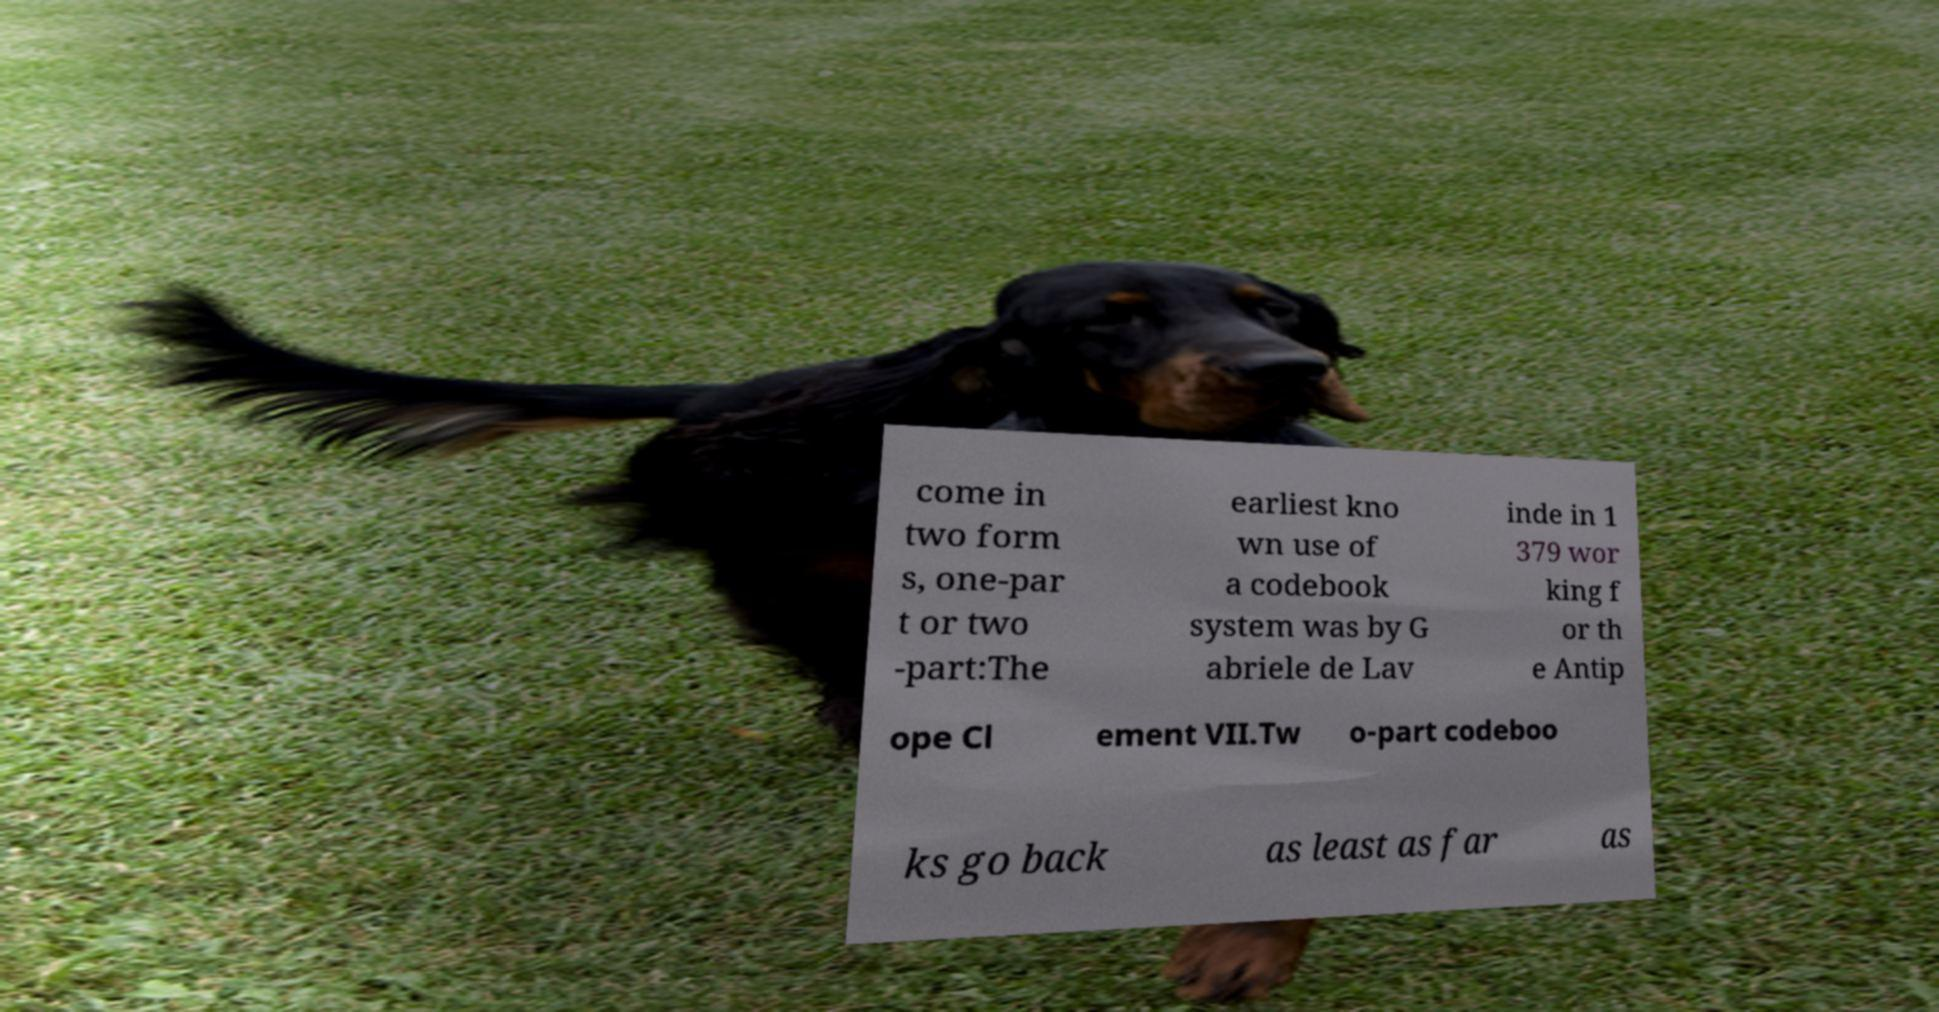Could you extract and type out the text from this image? come in two form s, one-par t or two -part:The earliest kno wn use of a codebook system was by G abriele de Lav inde in 1 379 wor king f or th e Antip ope Cl ement VII.Tw o-part codeboo ks go back as least as far as 